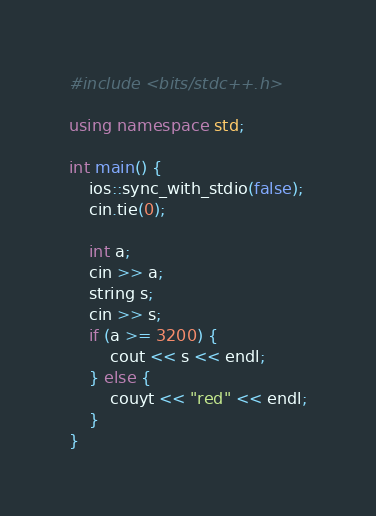<code> <loc_0><loc_0><loc_500><loc_500><_C++_>#include <bits/stdc++.h>

using namespace std;

int main() {
    ios::sync_with_stdio(false);
    cin.tie(0);

    int a;
    cin >> a;
    string s;
    cin >> s;
    if (a >= 3200) {
        cout << s << endl;
    } else {
        couyt << "red" << endl;
    }
}</code> 